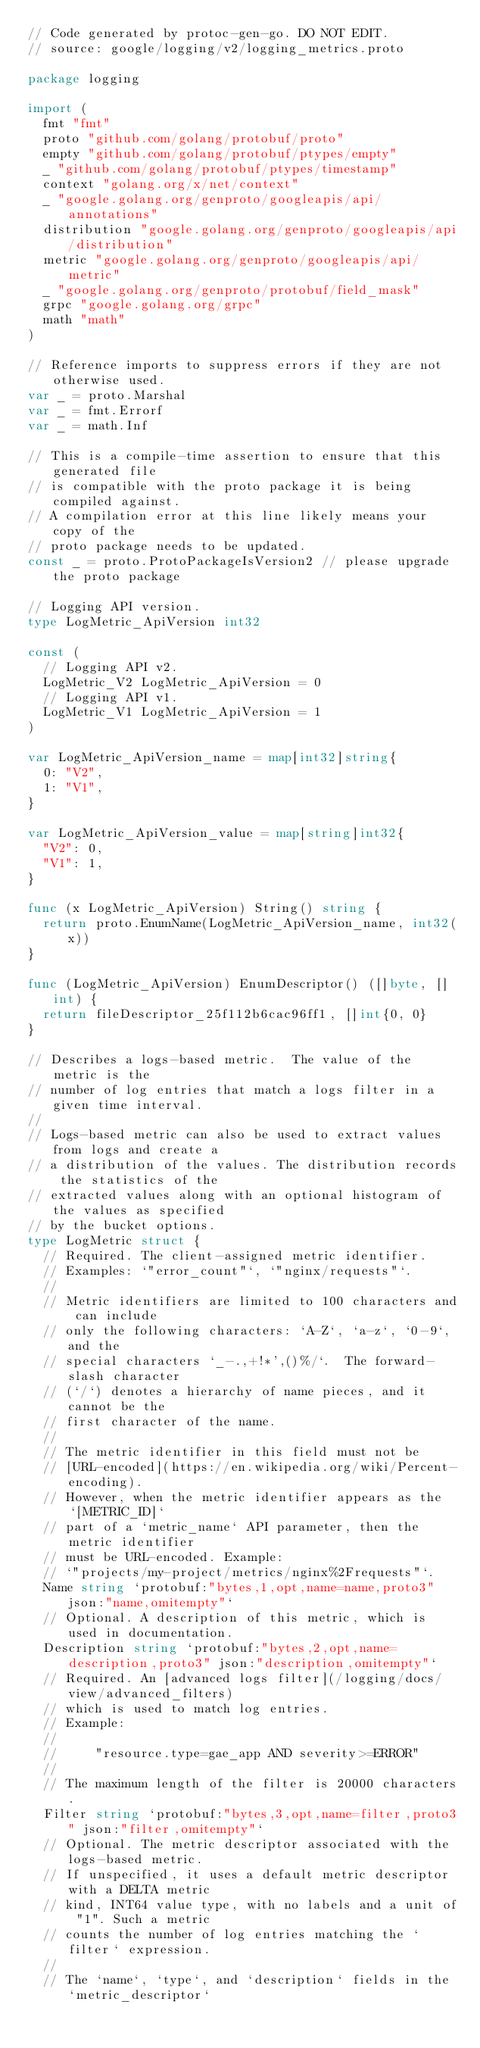<code> <loc_0><loc_0><loc_500><loc_500><_Go_>// Code generated by protoc-gen-go. DO NOT EDIT.
// source: google/logging/v2/logging_metrics.proto

package logging

import (
	fmt "fmt"
	proto "github.com/golang/protobuf/proto"
	empty "github.com/golang/protobuf/ptypes/empty"
	_ "github.com/golang/protobuf/ptypes/timestamp"
	context "golang.org/x/net/context"
	_ "google.golang.org/genproto/googleapis/api/annotations"
	distribution "google.golang.org/genproto/googleapis/api/distribution"
	metric "google.golang.org/genproto/googleapis/api/metric"
	_ "google.golang.org/genproto/protobuf/field_mask"
	grpc "google.golang.org/grpc"
	math "math"
)

// Reference imports to suppress errors if they are not otherwise used.
var _ = proto.Marshal
var _ = fmt.Errorf
var _ = math.Inf

// This is a compile-time assertion to ensure that this generated file
// is compatible with the proto package it is being compiled against.
// A compilation error at this line likely means your copy of the
// proto package needs to be updated.
const _ = proto.ProtoPackageIsVersion2 // please upgrade the proto package

// Logging API version.
type LogMetric_ApiVersion int32

const (
	// Logging API v2.
	LogMetric_V2 LogMetric_ApiVersion = 0
	// Logging API v1.
	LogMetric_V1 LogMetric_ApiVersion = 1
)

var LogMetric_ApiVersion_name = map[int32]string{
	0: "V2",
	1: "V1",
}

var LogMetric_ApiVersion_value = map[string]int32{
	"V2": 0,
	"V1": 1,
}

func (x LogMetric_ApiVersion) String() string {
	return proto.EnumName(LogMetric_ApiVersion_name, int32(x))
}

func (LogMetric_ApiVersion) EnumDescriptor() ([]byte, []int) {
	return fileDescriptor_25f112b6cac96ff1, []int{0, 0}
}

// Describes a logs-based metric.  The value of the metric is the
// number of log entries that match a logs filter in a given time interval.
//
// Logs-based metric can also be used to extract values from logs and create a
// a distribution of the values. The distribution records the statistics of the
// extracted values along with an optional histogram of the values as specified
// by the bucket options.
type LogMetric struct {
	// Required. The client-assigned metric identifier.
	// Examples: `"error_count"`, `"nginx/requests"`.
	//
	// Metric identifiers are limited to 100 characters and can include
	// only the following characters: `A-Z`, `a-z`, `0-9`, and the
	// special characters `_-.,+!*',()%/`.  The forward-slash character
	// (`/`) denotes a hierarchy of name pieces, and it cannot be the
	// first character of the name.
	//
	// The metric identifier in this field must not be
	// [URL-encoded](https://en.wikipedia.org/wiki/Percent-encoding).
	// However, when the metric identifier appears as the `[METRIC_ID]`
	// part of a `metric_name` API parameter, then the metric identifier
	// must be URL-encoded. Example:
	// `"projects/my-project/metrics/nginx%2Frequests"`.
	Name string `protobuf:"bytes,1,opt,name=name,proto3" json:"name,omitempty"`
	// Optional. A description of this metric, which is used in documentation.
	Description string `protobuf:"bytes,2,opt,name=description,proto3" json:"description,omitempty"`
	// Required. An [advanced logs filter](/logging/docs/view/advanced_filters)
	// which is used to match log entries.
	// Example:
	//
	//     "resource.type=gae_app AND severity>=ERROR"
	//
	// The maximum length of the filter is 20000 characters.
	Filter string `protobuf:"bytes,3,opt,name=filter,proto3" json:"filter,omitempty"`
	// Optional. The metric descriptor associated with the logs-based metric.
	// If unspecified, it uses a default metric descriptor with a DELTA metric
	// kind, INT64 value type, with no labels and a unit of "1". Such a metric
	// counts the number of log entries matching the `filter` expression.
	//
	// The `name`, `type`, and `description` fields in the `metric_descriptor`</code> 